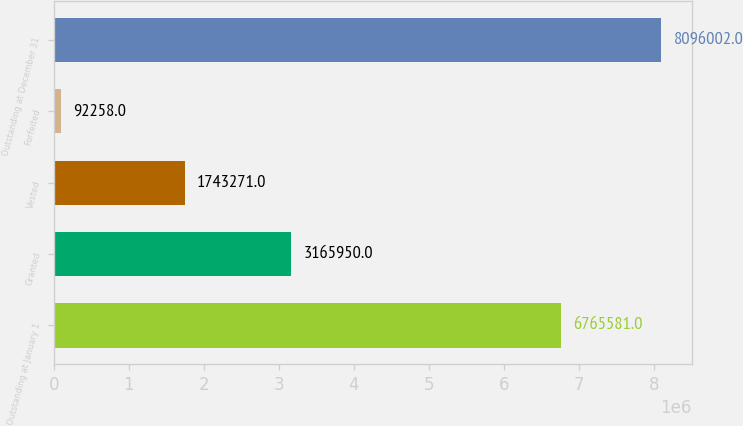<chart> <loc_0><loc_0><loc_500><loc_500><bar_chart><fcel>Outstanding at January 1<fcel>Granted<fcel>Vested<fcel>Forfeited<fcel>Outstanding at December 31<nl><fcel>6.76558e+06<fcel>3.16595e+06<fcel>1.74327e+06<fcel>92258<fcel>8.096e+06<nl></chart> 